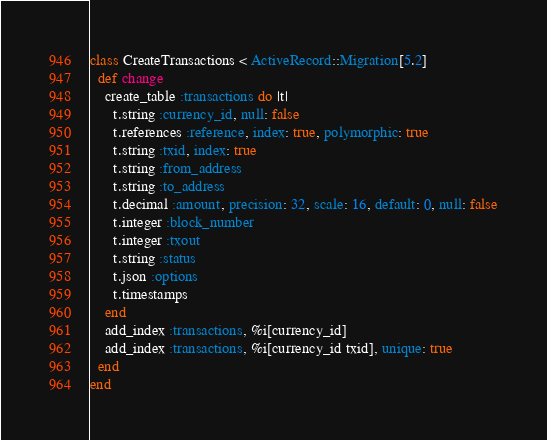Convert code to text. <code><loc_0><loc_0><loc_500><loc_500><_Ruby_>class CreateTransactions < ActiveRecord::Migration[5.2]
  def change
    create_table :transactions do |t|
      t.string :currency_id, null: false
      t.references :reference, index: true, polymorphic: true
      t.string :txid, index: true
      t.string :from_address
      t.string :to_address
      t.decimal :amount, precision: 32, scale: 16, default: 0, null: false
      t.integer :block_number
      t.integer :txout
      t.string :status
      t.json :options
      t.timestamps
    end
    add_index :transactions, %i[currency_id]
    add_index :transactions, %i[currency_id txid], unique: true
  end
end
</code> 